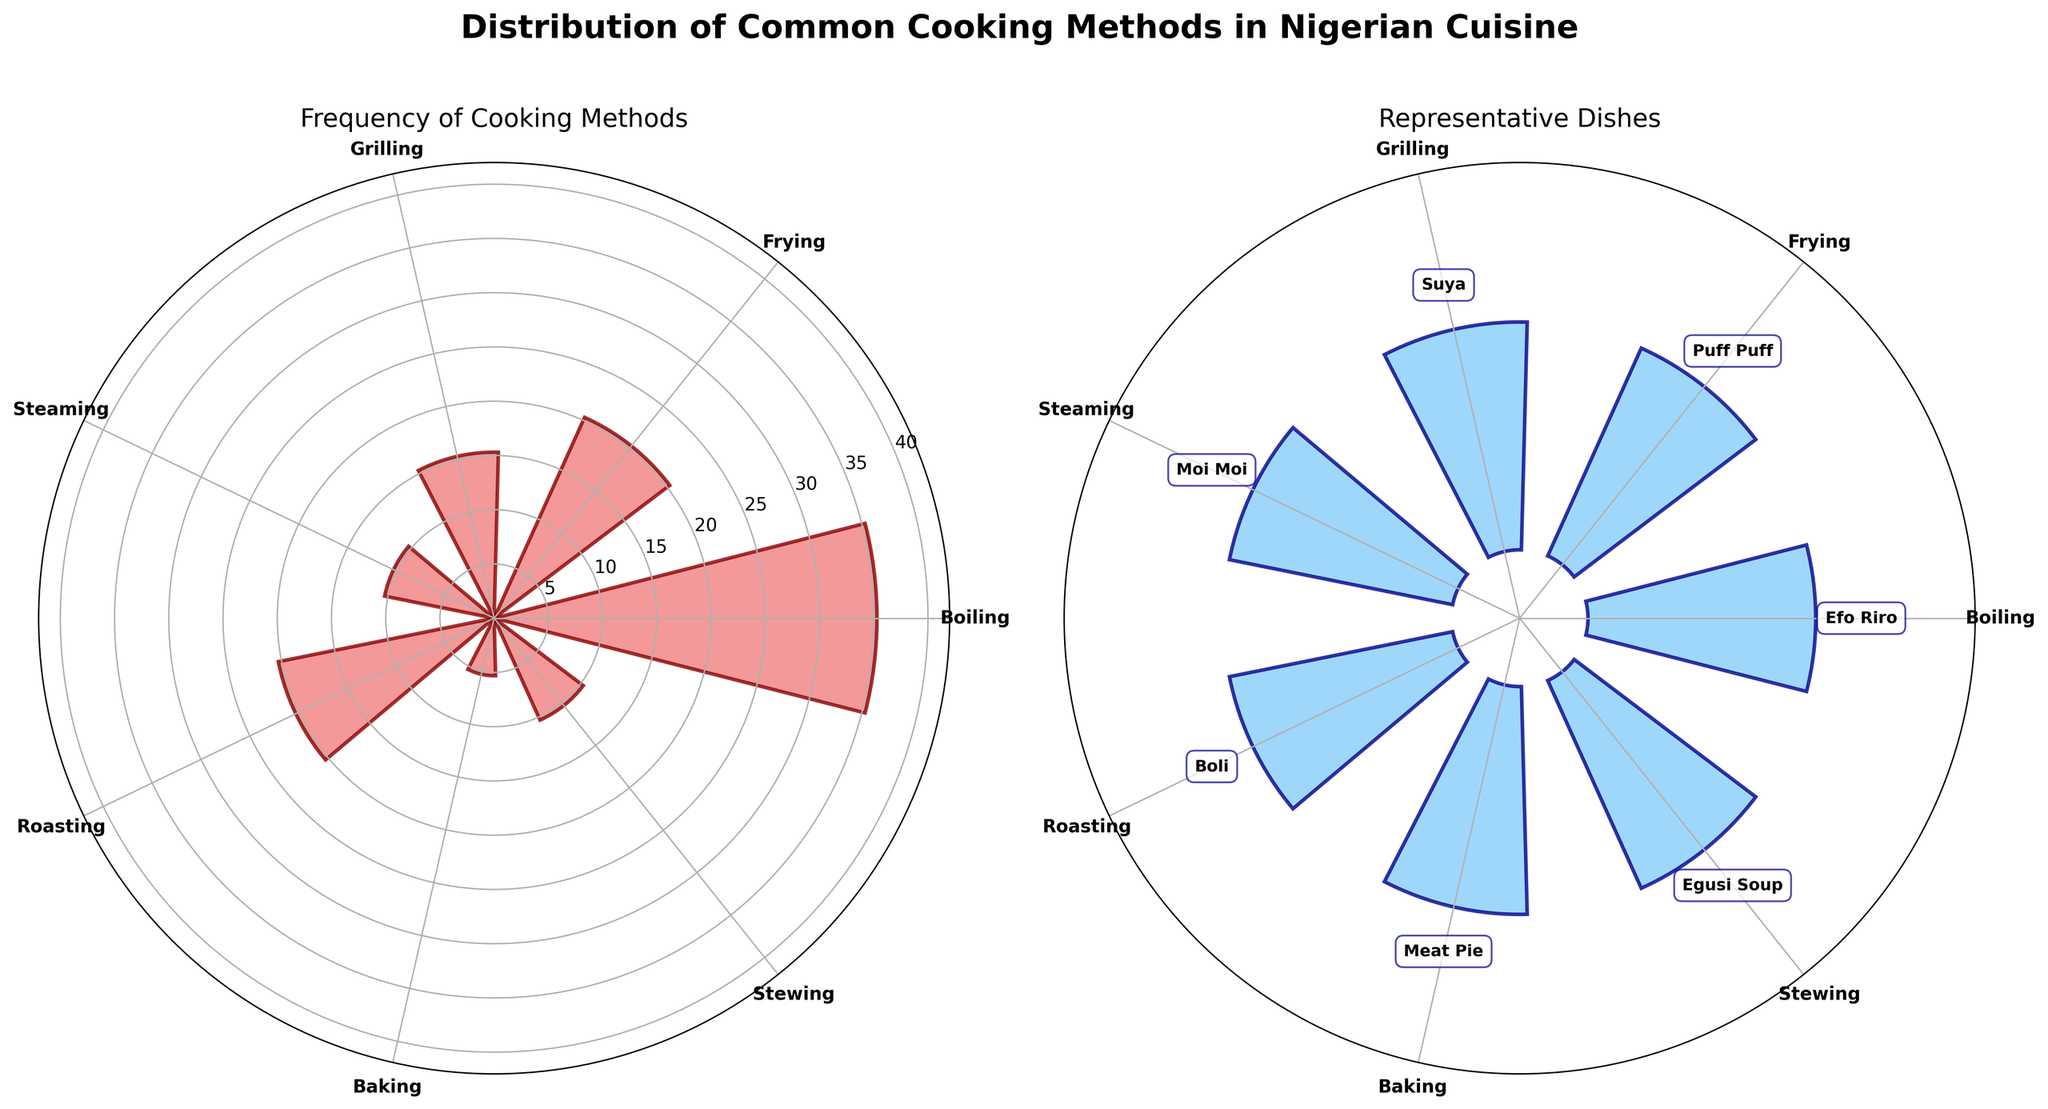What's the title of the plot? The title is shown at the top of the figure in bold and larger font size. It reads "Distribution of Common Cooking Methods in Nigerian Cuisine".
Answer: Distribution of Common Cooking Methods in Nigerian Cuisine Which cooking method has the highest frequency? The first subplot shows the frequency of cooking methods with bars. The tallest bar represents the cooking method with the highest frequency, which is "Boiling".
Answer: Boiling What's the representative dish for the method 'Frying'? The second subplot labels representative dishes for each cooking method. For "Frying", the dish labeled is "Puff Puff".
Answer: Puff Puff How many cooking methods have a frequency of 10? In the first subplot, two bars are at the height corresponding to a frequency of 10. These methods are "Steaming" and "Stewing".
Answer: 2 Which cooking method is used for both a spicy dish and a dessert? The second subplot lists dishes like "Suya" (spicy dish) and "Puff Puff" (dessert). The cooking methods for these dishes are "Grilling" and "Frying", respectively. No single method is used for both a spicy dish and a dessert.
Answer: None What's the combined frequency of Stewing and Roasting? From the first subplot, the frequency for "Stewing" is 10 and "Roasting" is 5 + 15 = 20 (both "Boli" and "Yam Porridge" are roasted). So, the combined frequency is 10 + 20 = 30.
Answer: 30 Which cooking method has the same frequency as the combined frequency of Baking and Steaming? The frequency for "Baking" is 5, and "Steaming" is 10. Their combined frequency is 5 + 10 = 15. The method "Grilling" has a frequency of 15, which is the same.
Answer: Grilling Which cooking method is least frequent? In the first subplot, the shortest bar represents the cooking method with the lowest frequency, which is "Baking" or "Roasting (Boli)".
Answer: Baking/Roasting (Boli) What color represents the bars in the second subplot? The second subplot shows bars in the color "lightskyblue", verified by the visual appearance.
Answer: lightskyblue 